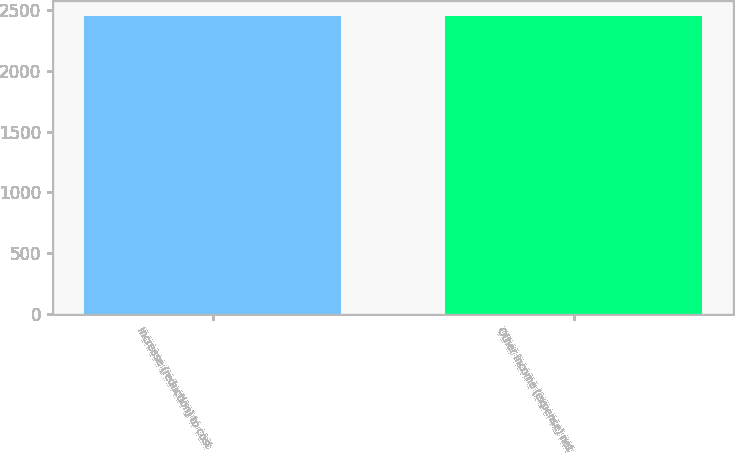Convert chart. <chart><loc_0><loc_0><loc_500><loc_500><bar_chart><fcel>Increase (reduction) to cost<fcel>Other income (expense) net<nl><fcel>2449<fcel>2449.1<nl></chart> 